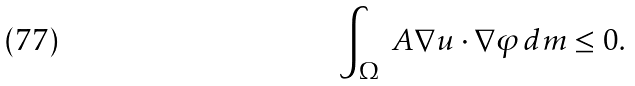<formula> <loc_0><loc_0><loc_500><loc_500>\int _ { \Omega } \ A \nabla u \cdot \nabla \varphi \, d m \leq 0 .</formula> 